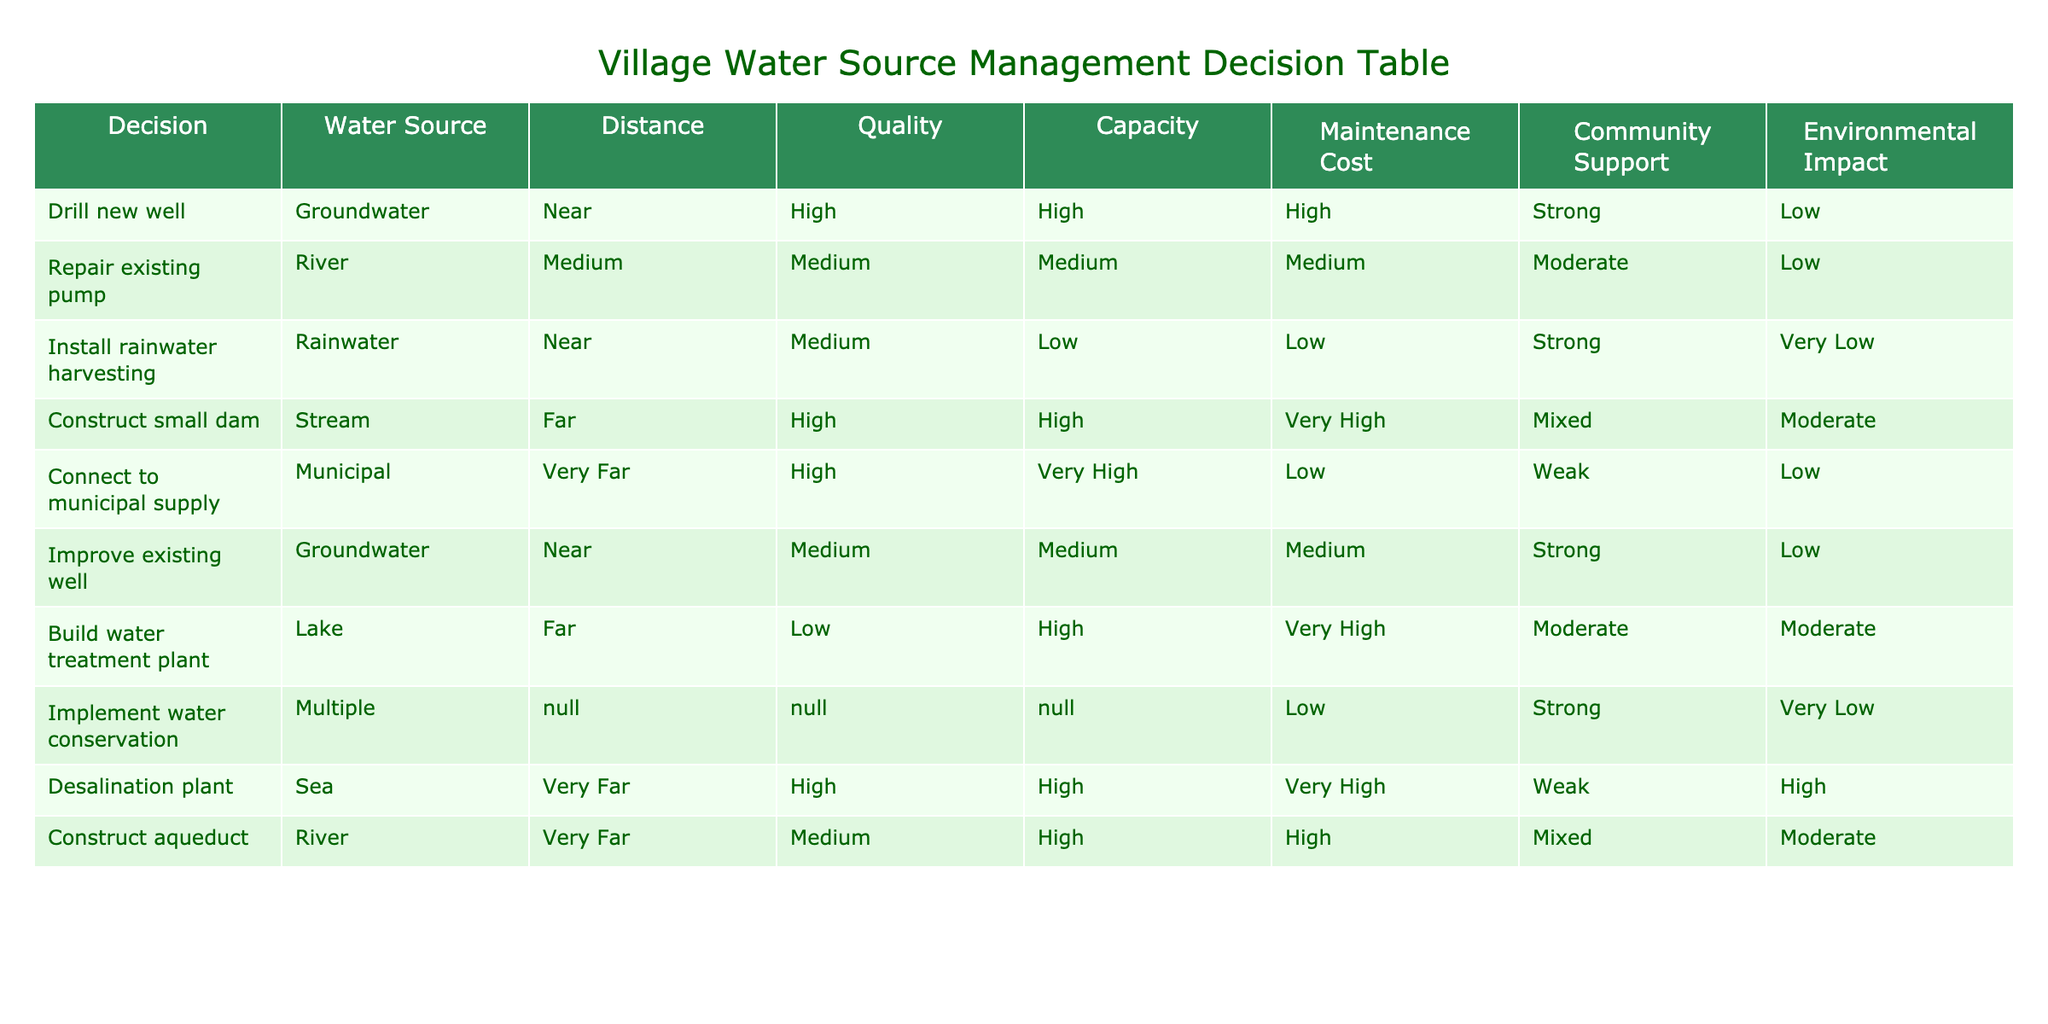What water source has the highest capacity? The table lists multiple water sources and their corresponding capacities. The highest capacity is noted under "Connect to municipal supply," with a classification of "Very High."
Answer: Very High Is the maintenance cost for the rainwater harvesting installation low? The maintenance cost listed for rainwater harvesting is "Low," indicating it is indeed low.
Answer: Yes How many water sources are near to the village? Upon reviewing the table, the water sources categorized as "Near" are: Drill new well, Install rainwater harvesting, Improve existing well. Therefore, there are 3 water sources that are near.
Answer: 3 Which water source option has a mixed community support? The community support labeled as "Mixed" can be found under both "Construct small dam" and "Construct aqueduct." This means there are two options with mixed support.
Answer: Construct small dam, Construct aqueduct What is the average maintenance cost of all water sources? The maintenance costs are: High (3), Medium (4), Low (3), Very High (3), and there are a total of 10 options. The sum of numerical values for easy calculation: High = 3, Medium = 2, Low = 1, Very High = 4. Now, add them up: (3x3 + 4x2 + 3x1 + 3x4) = 9 + 8 + 3 + 12 = 32. Thus, dividing by 10 gives an average maintenance cost of 32/10 = 3.2.
Answer: 3.2 Is it true that building a desalination plant has a high environmental impact? The table shows the environmental impact for the desalination plant is noted as "High." Therefore, it is true that it has a high environmental impact.
Answer: Yes 